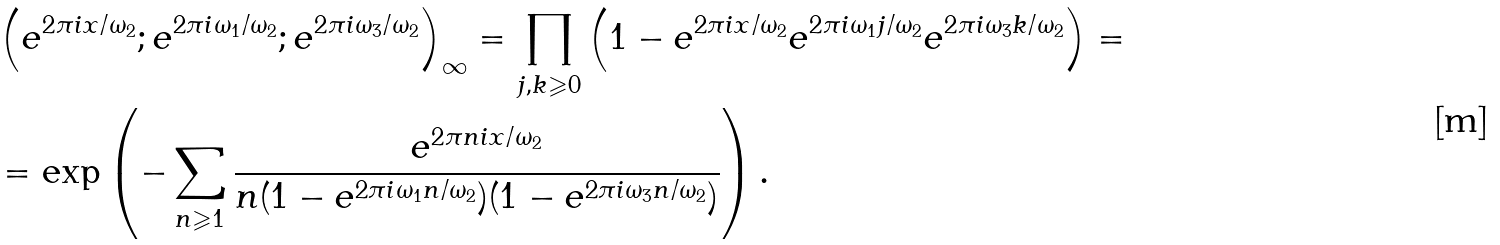Convert formula to latex. <formula><loc_0><loc_0><loc_500><loc_500>& \left ( e ^ { 2 \pi i x / \omega _ { 2 } } ; e ^ { 2 \pi i \omega _ { 1 } / \omega _ { 2 } } ; e ^ { 2 \pi i \omega _ { 3 } / \omega _ { 2 } } \right ) _ { \infty } = \prod _ { j , k \geqslant 0 } \left ( 1 - e ^ { 2 \pi i x / \omega _ { 2 } } e ^ { 2 \pi i \omega _ { 1 } j / \omega _ { 2 } } e ^ { 2 \pi i \omega _ { 3 } k / \omega _ { 2 } } \right ) = \\ & = \text {exp} \left ( - \sum _ { n \geqslant 1 } \frac { e ^ { 2 \pi n i x / \omega _ { 2 } } } { n ( 1 - e ^ { 2 \pi i \omega _ { 1 } n / \omega _ { 2 } } ) ( 1 - e ^ { 2 \pi i \omega _ { 3 } n / \omega _ { 2 } } ) } \right ) .</formula> 